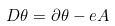<formula> <loc_0><loc_0><loc_500><loc_500>D \theta = \partial \theta - e A</formula> 